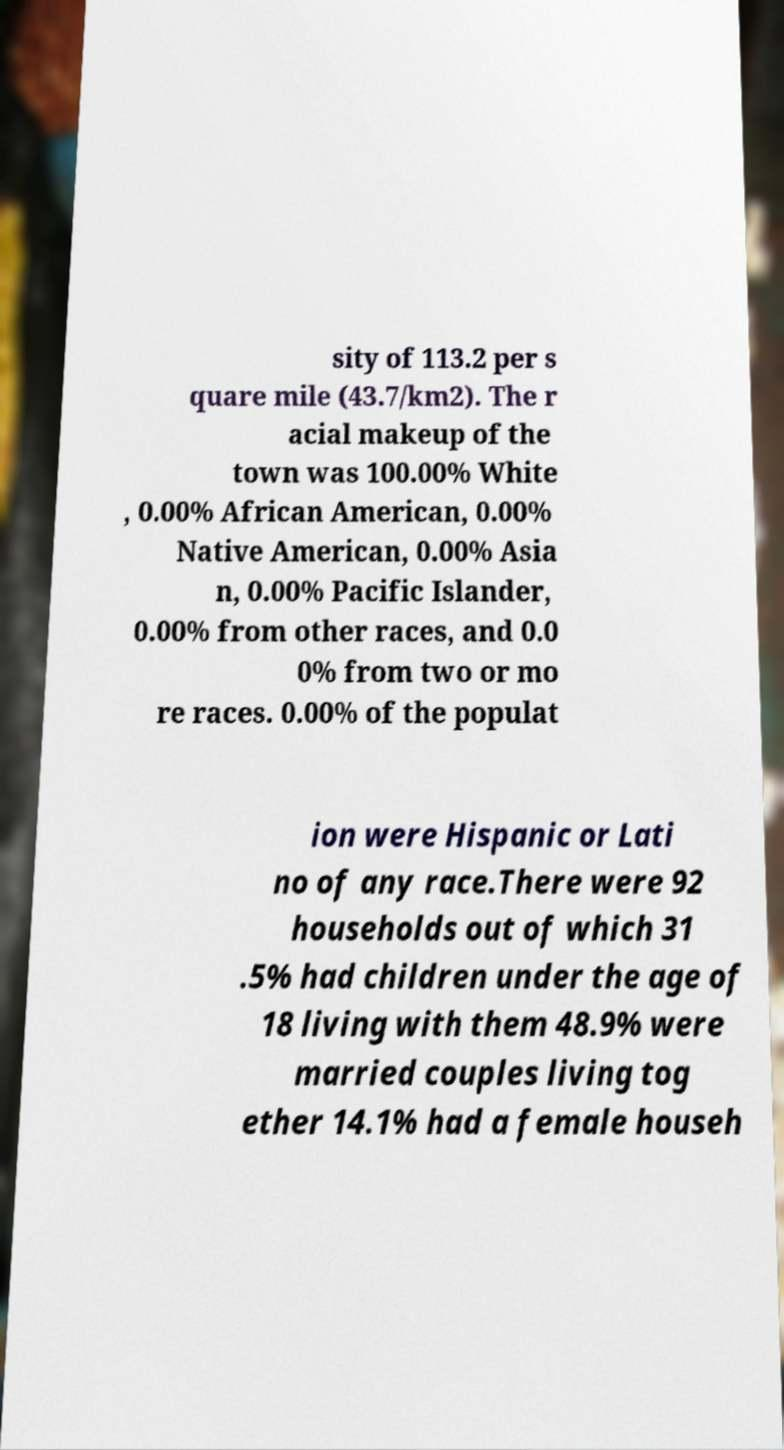Can you read and provide the text displayed in the image?This photo seems to have some interesting text. Can you extract and type it out for me? sity of 113.2 per s quare mile (43.7/km2). The r acial makeup of the town was 100.00% White , 0.00% African American, 0.00% Native American, 0.00% Asia n, 0.00% Pacific Islander, 0.00% from other races, and 0.0 0% from two or mo re races. 0.00% of the populat ion were Hispanic or Lati no of any race.There were 92 households out of which 31 .5% had children under the age of 18 living with them 48.9% were married couples living tog ether 14.1% had a female househ 